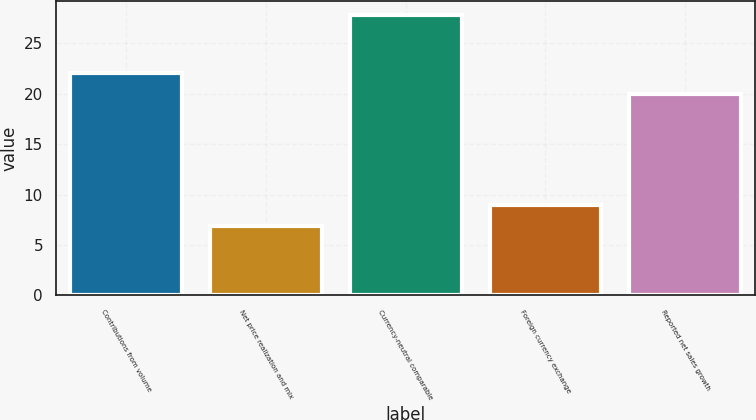<chart> <loc_0><loc_0><loc_500><loc_500><bar_chart><fcel>Contributions from volume<fcel>Net price realization and mix<fcel>Currency-neutral comparable<fcel>Foreign currency exchange<fcel>Reported net sales growth<nl><fcel>22.09<fcel>6.9<fcel>27.8<fcel>8.99<fcel>20<nl></chart> 